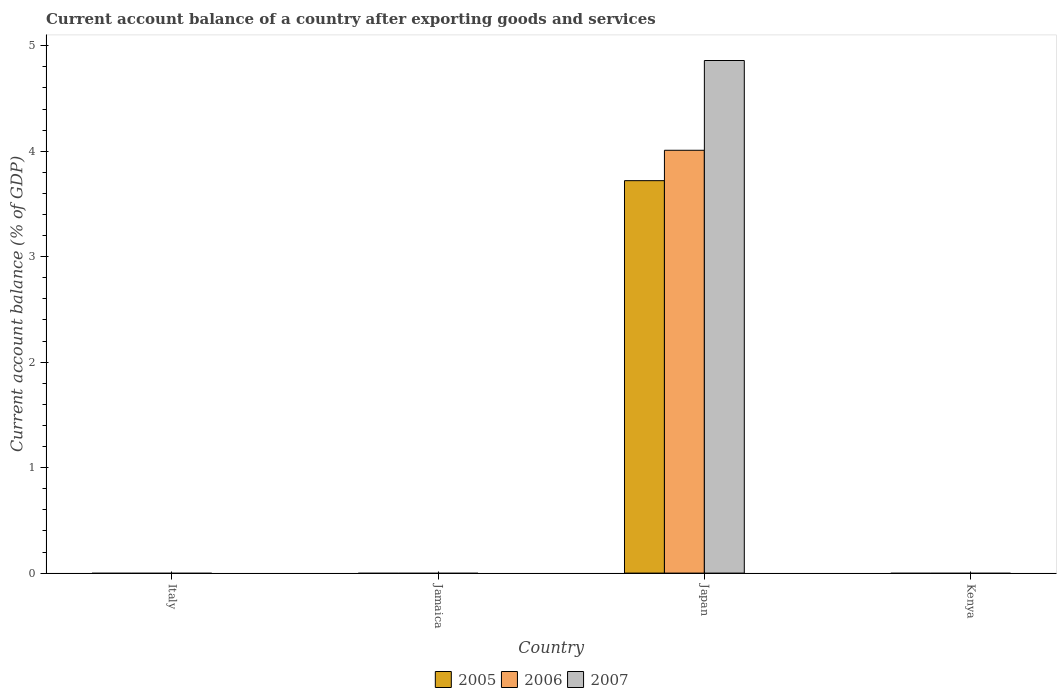How many different coloured bars are there?
Offer a very short reply. 3. Are the number of bars per tick equal to the number of legend labels?
Give a very brief answer. No. How many bars are there on the 4th tick from the left?
Provide a short and direct response. 0. In how many cases, is the number of bars for a given country not equal to the number of legend labels?
Your answer should be compact. 3. What is the account balance in 2007 in Japan?
Your answer should be very brief. 4.86. Across all countries, what is the maximum account balance in 2006?
Give a very brief answer. 4.01. In which country was the account balance in 2007 maximum?
Offer a terse response. Japan. What is the total account balance in 2007 in the graph?
Offer a very short reply. 4.86. What is the average account balance in 2005 per country?
Make the answer very short. 0.93. What is the difference between the account balance of/in 2007 and account balance of/in 2006 in Japan?
Offer a terse response. 0.85. In how many countries, is the account balance in 2007 greater than 1.4 %?
Ensure brevity in your answer.  1. What is the difference between the highest and the lowest account balance in 2007?
Provide a succinct answer. 4.86. Are all the bars in the graph horizontal?
Offer a terse response. No. What is the difference between two consecutive major ticks on the Y-axis?
Make the answer very short. 1. Are the values on the major ticks of Y-axis written in scientific E-notation?
Your answer should be compact. No. Does the graph contain any zero values?
Provide a short and direct response. Yes. Does the graph contain grids?
Ensure brevity in your answer.  No. How many legend labels are there?
Offer a very short reply. 3. What is the title of the graph?
Keep it short and to the point. Current account balance of a country after exporting goods and services. Does "1966" appear as one of the legend labels in the graph?
Your answer should be compact. No. What is the label or title of the Y-axis?
Keep it short and to the point. Current account balance (% of GDP). What is the Current account balance (% of GDP) of 2005 in Italy?
Your answer should be very brief. 0. What is the Current account balance (% of GDP) in 2006 in Italy?
Provide a succinct answer. 0. What is the Current account balance (% of GDP) in 2007 in Jamaica?
Provide a succinct answer. 0. What is the Current account balance (% of GDP) of 2005 in Japan?
Keep it short and to the point. 3.72. What is the Current account balance (% of GDP) of 2006 in Japan?
Make the answer very short. 4.01. What is the Current account balance (% of GDP) in 2007 in Japan?
Provide a succinct answer. 4.86. What is the Current account balance (% of GDP) of 2005 in Kenya?
Your answer should be compact. 0. What is the Current account balance (% of GDP) of 2006 in Kenya?
Provide a succinct answer. 0. What is the Current account balance (% of GDP) in 2007 in Kenya?
Your answer should be compact. 0. Across all countries, what is the maximum Current account balance (% of GDP) of 2005?
Offer a terse response. 3.72. Across all countries, what is the maximum Current account balance (% of GDP) of 2006?
Your answer should be very brief. 4.01. Across all countries, what is the maximum Current account balance (% of GDP) in 2007?
Make the answer very short. 4.86. What is the total Current account balance (% of GDP) in 2005 in the graph?
Give a very brief answer. 3.72. What is the total Current account balance (% of GDP) of 2006 in the graph?
Your response must be concise. 4.01. What is the total Current account balance (% of GDP) of 2007 in the graph?
Offer a terse response. 4.86. What is the average Current account balance (% of GDP) in 2005 per country?
Provide a short and direct response. 0.93. What is the average Current account balance (% of GDP) in 2006 per country?
Your response must be concise. 1. What is the average Current account balance (% of GDP) in 2007 per country?
Offer a terse response. 1.22. What is the difference between the Current account balance (% of GDP) in 2005 and Current account balance (% of GDP) in 2006 in Japan?
Offer a terse response. -0.29. What is the difference between the Current account balance (% of GDP) of 2005 and Current account balance (% of GDP) of 2007 in Japan?
Your response must be concise. -1.14. What is the difference between the Current account balance (% of GDP) of 2006 and Current account balance (% of GDP) of 2007 in Japan?
Your answer should be compact. -0.85. What is the difference between the highest and the lowest Current account balance (% of GDP) of 2005?
Ensure brevity in your answer.  3.72. What is the difference between the highest and the lowest Current account balance (% of GDP) of 2006?
Your answer should be compact. 4.01. What is the difference between the highest and the lowest Current account balance (% of GDP) in 2007?
Ensure brevity in your answer.  4.86. 